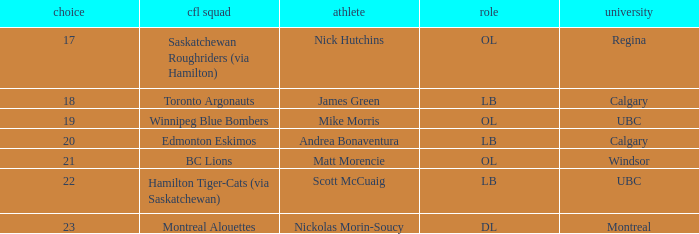What position is the player who went to Regina?  OL. 